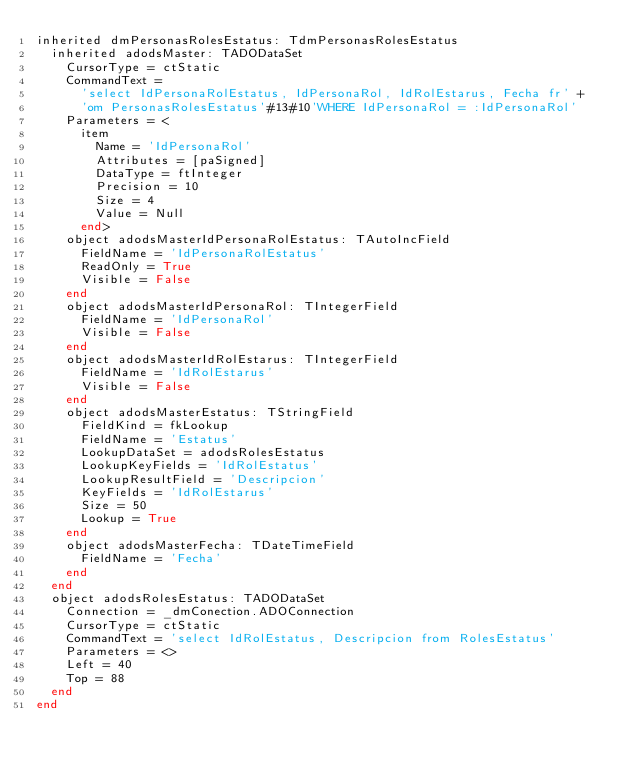Convert code to text. <code><loc_0><loc_0><loc_500><loc_500><_Pascal_>inherited dmPersonasRolesEstatus: TdmPersonasRolesEstatus
  inherited adodsMaster: TADODataSet
    CursorType = ctStatic
    CommandText = 
      'select IdPersonaRolEstatus, IdPersonaRol, IdRolEstarus, Fecha fr' +
      'om PersonasRolesEstatus'#13#10'WHERE IdPersonaRol = :IdPersonaRol'
    Parameters = <
      item
        Name = 'IdPersonaRol'
        Attributes = [paSigned]
        DataType = ftInteger
        Precision = 10
        Size = 4
        Value = Null
      end>
    object adodsMasterIdPersonaRolEstatus: TAutoIncField
      FieldName = 'IdPersonaRolEstatus'
      ReadOnly = True
      Visible = False
    end
    object adodsMasterIdPersonaRol: TIntegerField
      FieldName = 'IdPersonaRol'
      Visible = False
    end
    object adodsMasterIdRolEstarus: TIntegerField
      FieldName = 'IdRolEstarus'
      Visible = False
    end
    object adodsMasterEstatus: TStringField
      FieldKind = fkLookup
      FieldName = 'Estatus'
      LookupDataSet = adodsRolesEstatus
      LookupKeyFields = 'IdRolEstatus'
      LookupResultField = 'Descripcion'
      KeyFields = 'IdRolEstarus'
      Size = 50
      Lookup = True
    end
    object adodsMasterFecha: TDateTimeField
      FieldName = 'Fecha'
    end
  end
  object adodsRolesEstatus: TADODataSet
    Connection = _dmConection.ADOConnection
    CursorType = ctStatic
    CommandText = 'select IdRolEstatus, Descripcion from RolesEstatus'
    Parameters = <>
    Left = 40
    Top = 88
  end
end
</code> 